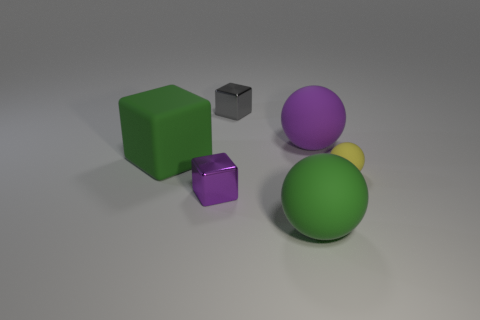There is a tiny object on the right side of the gray object; what color is it?
Your answer should be compact. Yellow. The green block that is the same material as the tiny yellow sphere is what size?
Keep it short and to the point. Large. How many green things are behind the big thing that is in front of the tiny purple block?
Make the answer very short. 1. What number of purple shiny things are behind the tiny purple metal object?
Your response must be concise. 0. What color is the tiny thing that is left of the small shiny cube behind the tiny metal thing in front of the small gray cube?
Offer a very short reply. Purple. Is the color of the block behind the large purple object the same as the tiny block in front of the small gray block?
Your answer should be very brief. No. The object behind the rubber sphere behind the big green matte block is what shape?
Provide a succinct answer. Cube. Are there any purple objects that have the same size as the gray metal thing?
Ensure brevity in your answer.  Yes. What number of big green objects have the same shape as the yellow thing?
Provide a succinct answer. 1. Are there the same number of cubes in front of the purple metal thing and big green matte spheres that are behind the large purple sphere?
Give a very brief answer. Yes. 